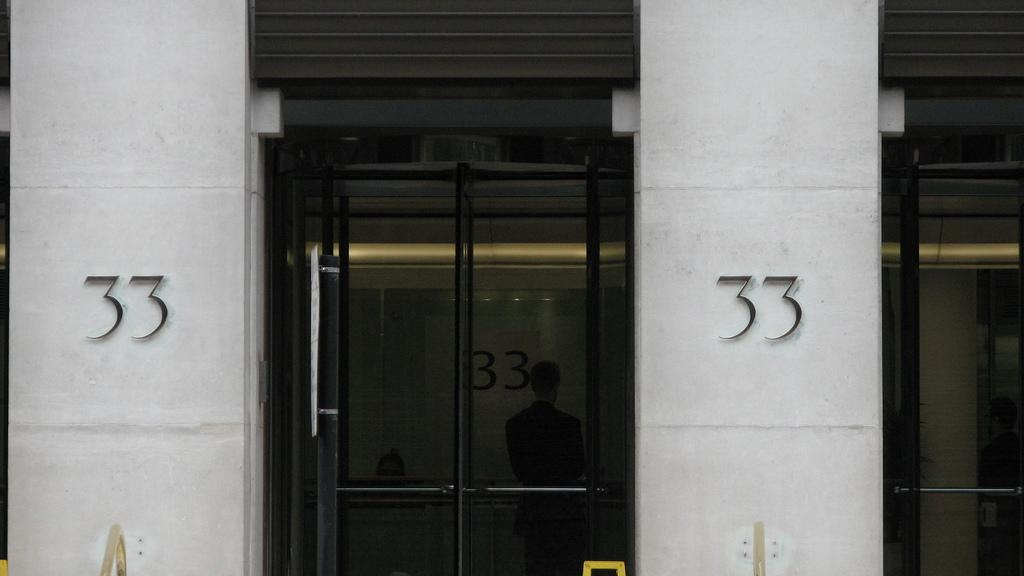What type of structure is shown in the image? The image depicts a building. What feature can be seen on the building's entrance? There are glass doors in the building. What can be found on the wall inside the building? There are numbers visible on the wall, and there are also plug boards on the wall. Can you tell me how many bees are buzzing around the wall in the image? There are no bees present in the image; the focus is on the building, glass doors, numbers, and plug boards. What type of reward is shown hanging on the wall in the image? There is no reward visible in the image; the focus is on the building, glass doors, numbers, and plug boards. 